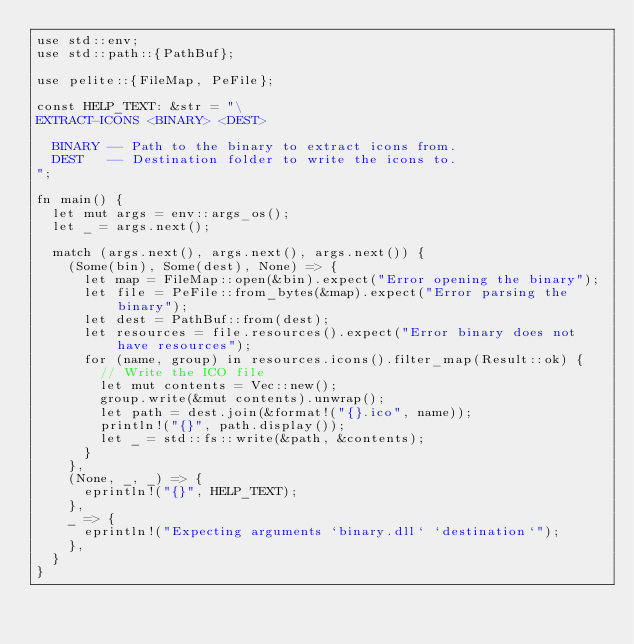Convert code to text. <code><loc_0><loc_0><loc_500><loc_500><_Rust_>use std::env;
use std::path::{PathBuf};

use pelite::{FileMap, PeFile};

const HELP_TEXT: &str = "\
EXTRACT-ICONS <BINARY> <DEST>

  BINARY -- Path to the binary to extract icons from.
  DEST   -- Destination folder to write the icons to.
";

fn main() {
	let mut args = env::args_os();
	let _ = args.next();

	match (args.next(), args.next(), args.next()) {
		(Some(bin), Some(dest), None) => {
			let map = FileMap::open(&bin).expect("Error opening the binary");
			let file = PeFile::from_bytes(&map).expect("Error parsing the binary");
			let dest = PathBuf::from(dest);
			let resources = file.resources().expect("Error binary does not have resources");
			for (name, group) in resources.icons().filter_map(Result::ok) {
				// Write the ICO file
				let mut contents = Vec::new();
				group.write(&mut contents).unwrap();
				let path = dest.join(&format!("{}.ico", name));
				println!("{}", path.display());
				let _ = std::fs::write(&path, &contents);
			}
		},
		(None, _, _) => {
			eprintln!("{}", HELP_TEXT);
		},
		_ => {
			eprintln!("Expecting arguments `binary.dll` `destination`");
		},
	}
}
</code> 